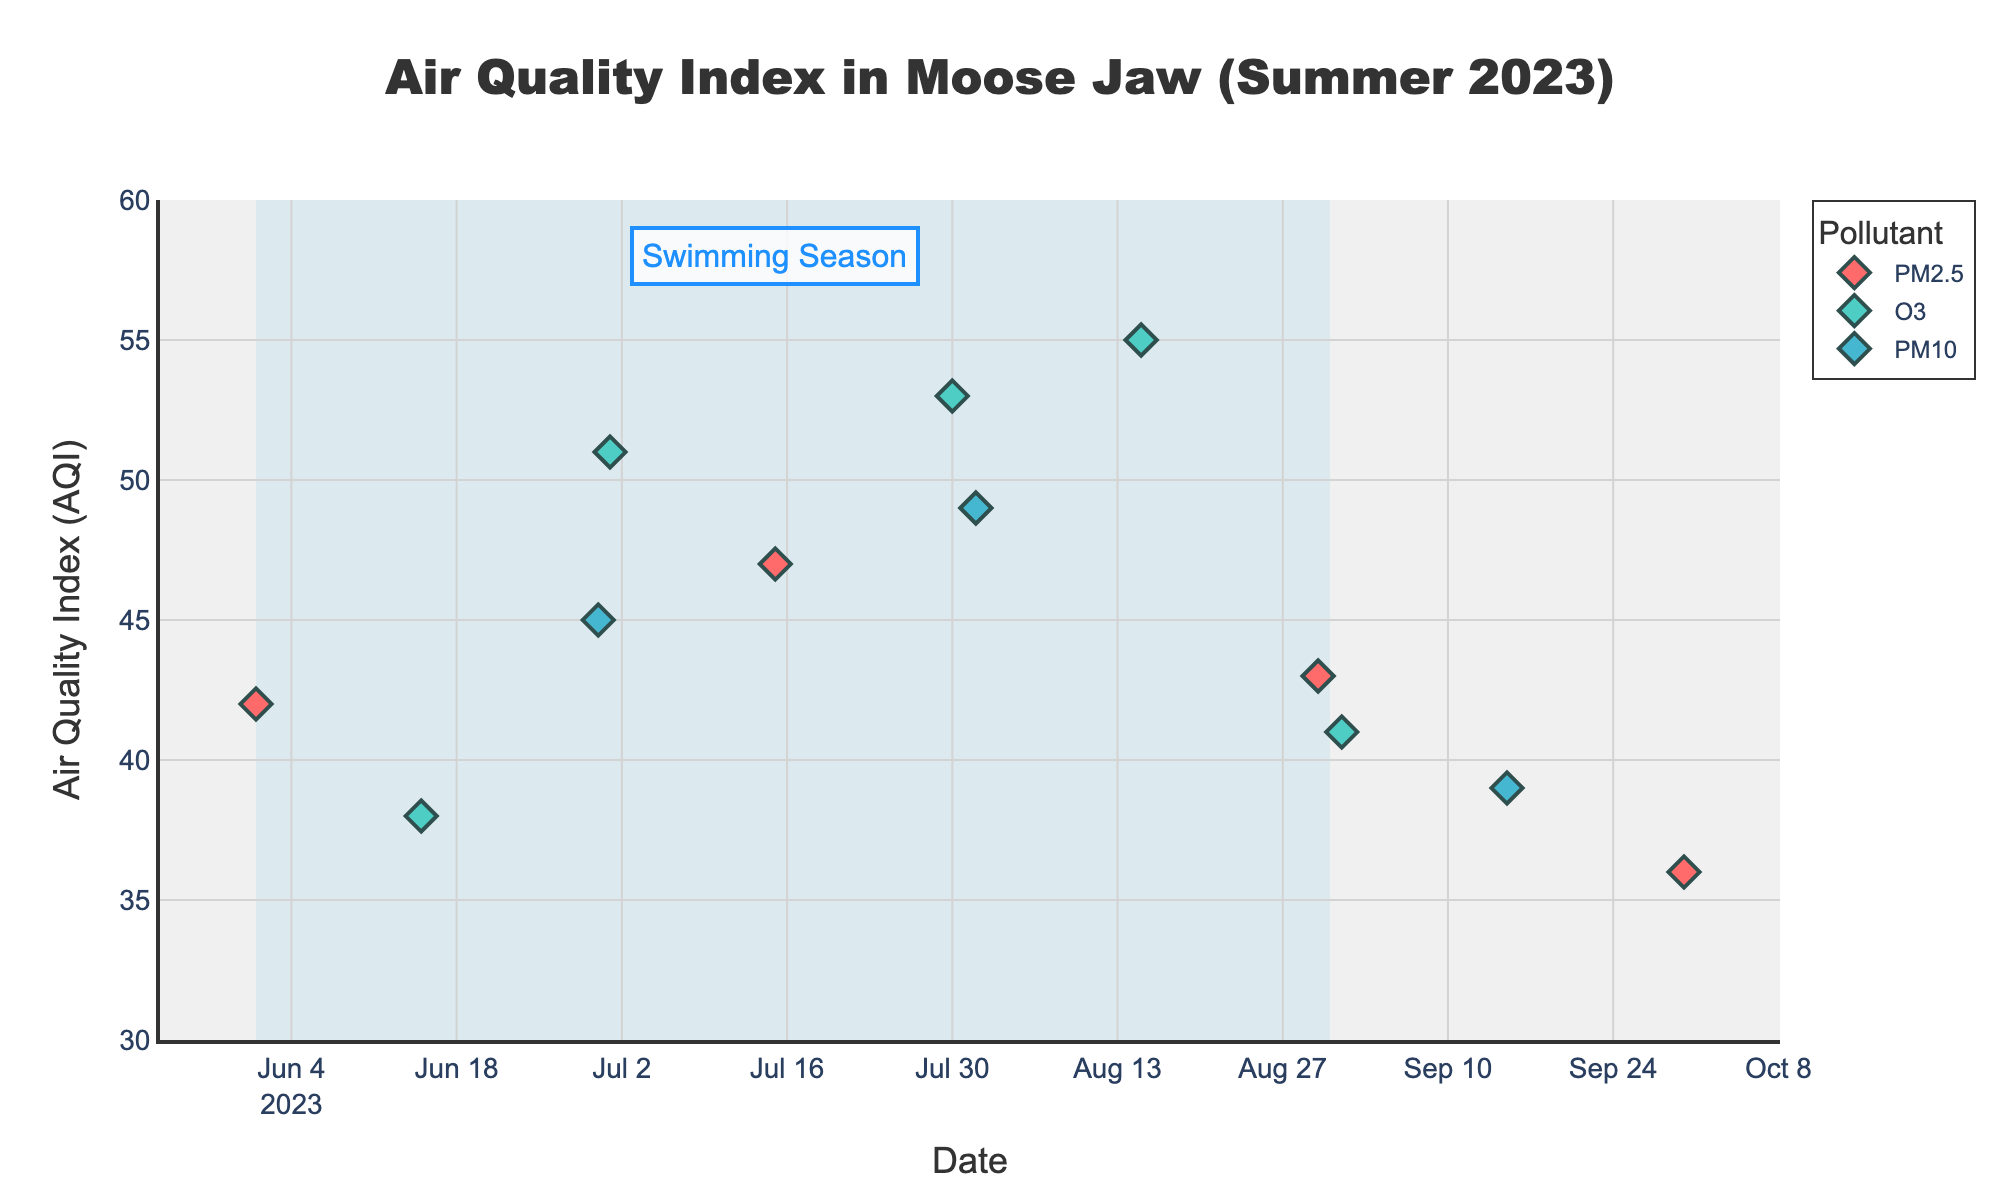What is the title of the plot? The title of the plot is displayed at the top center of the figure and reads "Air Quality Index in Moose Jaw (Summer 2023)".
Answer: Air Quality Index in Moose Jaw (Summer 2023) How many pollutants are displayed in the plot? The legend shows the different pollutants represented in the figure. There are three pollutants: PM2.5, O3, and PM10.
Answer: 3 Which pollutant shows the highest AQI value and on what date? The pollutant with the highest AQI value needs to be identified by looking at the highest y-axis value and cross-referencing with the corresponding x-axis date and legend color. The highest AQI value is 55 for O3 on 2023-08-15.
Answer: O3 on 2023-08-15 How do the AQI values for O3 change from June 1 to August 30? The AQI values for O3 need to be plotted chronologically to observe the trend. From June 1 (AQI of 38) to August 30 (AQI of 55), the AQI values increase.
Answer: Increase What is the average AQI value for PM2.5 during the summer months? The summer months are highlighted, and for PM2.5 entries, the AQI values (42 on 2023-06-01, 47 on 2023-07-15, and 43 on 2023-08-30) sum to 132. The count is 3, so the average is 132/3 = 44.
Answer: 44 Compare the AQI values of PM10 on June 30 and August 1. Which is higher? The AQI value for PM10 on June 30 is 45 and on August 1 is 49. Since 49 is greater than 45, August 1 has a higher AQI value.
Answer: August 1 How often does the AQI for any pollutant reach or exceed 50? Count the data points in the plot where the AQI value is 50 or higher. There are two such instances: 2023-07-01 (AQI of 51) and 2023-07-30 (AQI of 53).
Answer: 2 What is the range of AQI values shown in the plot? From the y-axis, the lowest AQI value is 36 and the highest is 55. The range is calculated as 55 - 36 = 19.
Answer: 19 Which pollutant had the highest frequency of AQI measurements above 45? By observing the plotted points for each pollutant, count how many times the AQI values exceeded 45 for each pollutant. O3 had the most instances with 3 measurements (51, 53, 55).
Answer: O3 